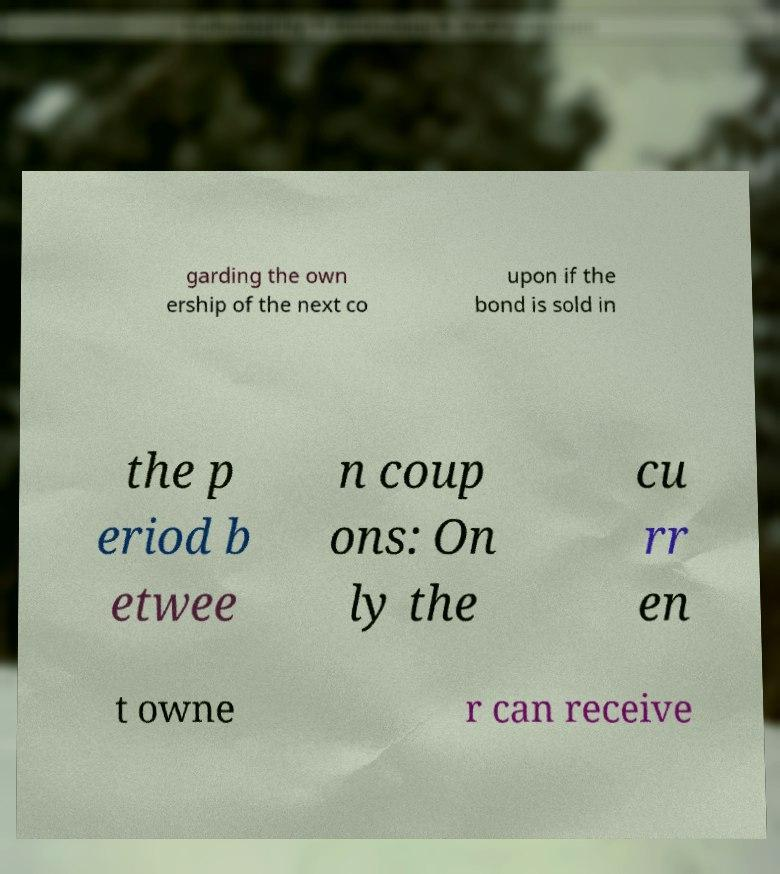Please read and relay the text visible in this image. What does it say? garding the own ership of the next co upon if the bond is sold in the p eriod b etwee n coup ons: On ly the cu rr en t owne r can receive 